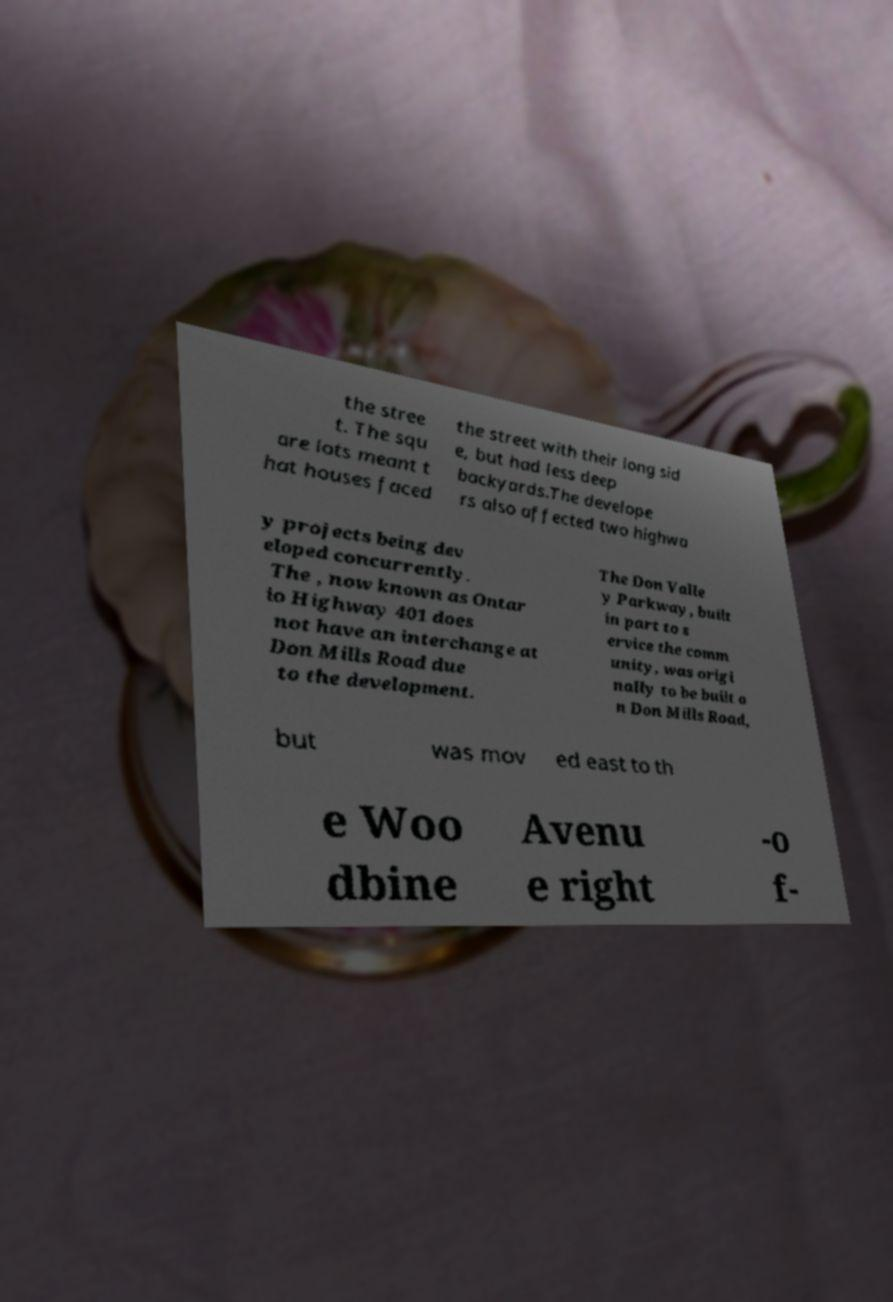Could you assist in decoding the text presented in this image and type it out clearly? the stree t. The squ are lots meant t hat houses faced the street with their long sid e, but had less deep backyards.The develope rs also affected two highwa y projects being dev eloped concurrently. The , now known as Ontar io Highway 401 does not have an interchange at Don Mills Road due to the development. The Don Valle y Parkway, built in part to s ervice the comm unity, was origi nally to be built o n Don Mills Road, but was mov ed east to th e Woo dbine Avenu e right -o f- 